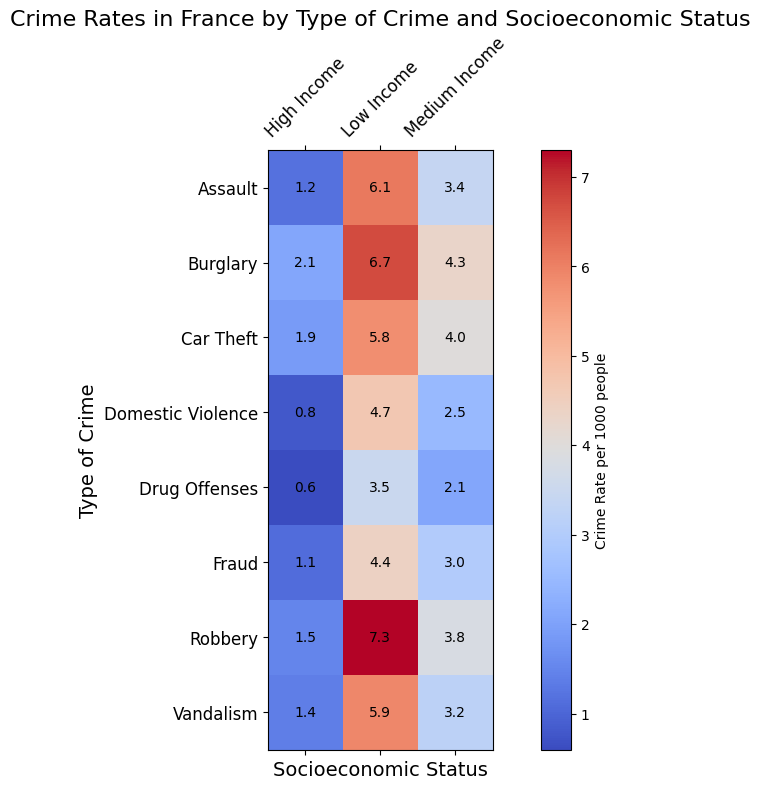Which type of crime has the highest rate in low-income areas? Look at the row labeled "Low Income" and find the highest value in this row. The highest crime rate per 1000 people is for "Robbery" at 7.3.
Answer: Robbery How does the crime rate of Domestic Violence compare between high and low-income areas? Check the crime rate for Domestic Violence in both high-income (0.8) and low-income (4.7) areas. The rate is higher in low-income areas.
Answer: Higher in low-income areas Which type of crime shows the smallest difference in rates between high-income and low-income areas? Subtract the crime rates in high-income areas from those in low-income areas for each type of crime and find the smallest difference. Domestic Violence: 4.7 - 0.8 = 3.9, Drug Offenses: 3.5 - 0.6 = 2.9, etc. The smallest difference is for Drug Offenses (2.9).
Answer: Drug Offenses What is the average crime rate for Medium Income areas across all crimes? Add the crime rates for Medium Income areas across all crime types and then divide by the total number of crime types: (4.3 + 3.8 + 3.4 + 4.0 + 2.1 + 3.2 + 2.5 + 3.0) / 8 = 25.3 / 8 = 3.1625.
Answer: 3.2 Which crimes have a higher rate in Medium Income areas compared to High Income areas? Compare each crime rate in Medium Income areas with those in High Income areas: Burglary (4.3 > 2.1), Robbery (3.8 > 1.5), etc. All crimes have higher rates in Medium Income areas compared to High Income.
Answer: All crimes How does the visual intensity of the colors indicate the crime rates across different socioeconomic statuses? Darker or more intense colors indicate higher crime rates. Therefore, lower-income areas generally have the most intense colors, showing higher crime rates.
Answer: More intense colors indicate higher crime rates Which type of crime's rate changes the most from Medium Income to Low Income areas? Calculate the difference between Medium Income and Low Income rates for each crime and find the largest difference. For instance, Robbery: 7.3 - 3.8 = 3.5, Assault: 6.1 - 3.4 = 2.7, etc. The largest difference is for Robbery (3.5).
Answer: Robbery What can be inferred about Fraud rates across different socioeconomic statuses? Examine the crime rates for Fraud: High Income (1.1), Medium Income (3.0), Low Income (4.4). Fraud rates increase as socioeconomic status decreases.
Answer: Fraud rates increase as socioeconomic status decreases What is the combined crime rate for Burglaries and Car Theft in Low Income areas? Add the crime rates for Burglary (6.7) and Car Theft (5.8) in Low Income areas. 6.7 + 5.8 = 12.5.
Answer: 12.5 In which socioeconomic status do Assault rates vary the least across different types of crimes? Compare the variability (spread) of Assault rates across Low, Medium, and High Income areas. High Income varies between 0.8 and 2.1 (span = 1.3), Medium Income varies between 2.1 and 4.3 (span = 2.2), and Low Income varies between 3.5 and 7.3 (span = 3.8). The least variable is High Income.
Answer: High Income 